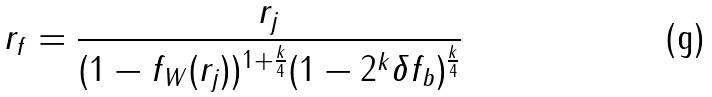<formula> <loc_0><loc_0><loc_500><loc_500>r _ { f } = \frac { r _ { j } } { ( 1 - f _ { W } ( r _ { j } ) ) ^ { 1 + \frac { k } { 4 } } ( 1 - 2 ^ { k } \delta f _ { b } ) ^ { \frac { k } { 4 } } }</formula> 